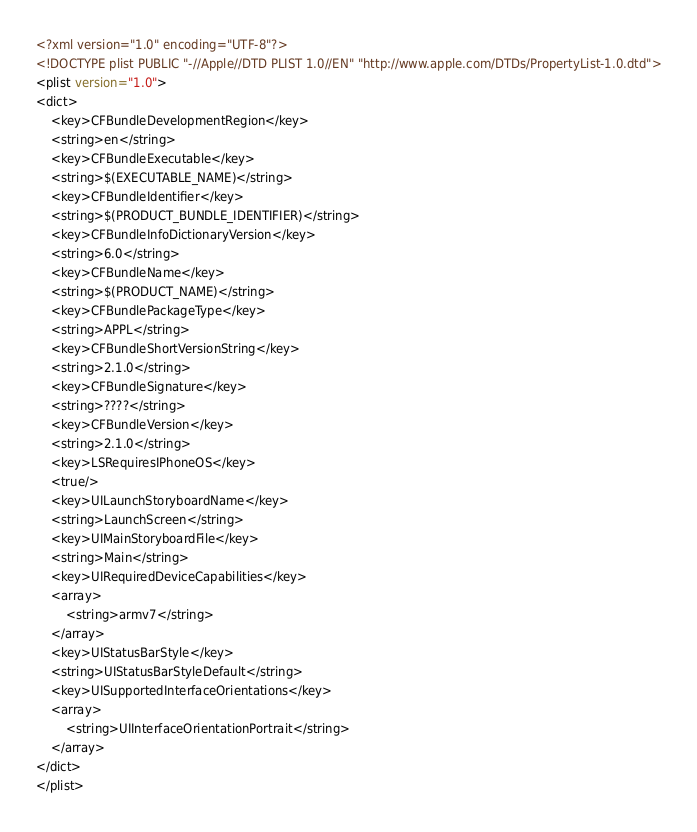Convert code to text. <code><loc_0><loc_0><loc_500><loc_500><_XML_><?xml version="1.0" encoding="UTF-8"?>
<!DOCTYPE plist PUBLIC "-//Apple//DTD PLIST 1.0//EN" "http://www.apple.com/DTDs/PropertyList-1.0.dtd">
<plist version="1.0">
<dict>
	<key>CFBundleDevelopmentRegion</key>
	<string>en</string>
	<key>CFBundleExecutable</key>
	<string>$(EXECUTABLE_NAME)</string>
	<key>CFBundleIdentifier</key>
	<string>$(PRODUCT_BUNDLE_IDENTIFIER)</string>
	<key>CFBundleInfoDictionaryVersion</key>
	<string>6.0</string>
	<key>CFBundleName</key>
	<string>$(PRODUCT_NAME)</string>
	<key>CFBundlePackageType</key>
	<string>APPL</string>
	<key>CFBundleShortVersionString</key>
	<string>2.1.0</string>
	<key>CFBundleSignature</key>
	<string>????</string>
	<key>CFBundleVersion</key>
	<string>2.1.0</string>
	<key>LSRequiresIPhoneOS</key>
	<true/>
	<key>UILaunchStoryboardName</key>
	<string>LaunchScreen</string>
	<key>UIMainStoryboardFile</key>
	<string>Main</string>
	<key>UIRequiredDeviceCapabilities</key>
	<array>
		<string>armv7</string>
	</array>
	<key>UIStatusBarStyle</key>
	<string>UIStatusBarStyleDefault</string>
	<key>UISupportedInterfaceOrientations</key>
	<array>
		<string>UIInterfaceOrientationPortrait</string>
	</array>
</dict>
</plist>
</code> 